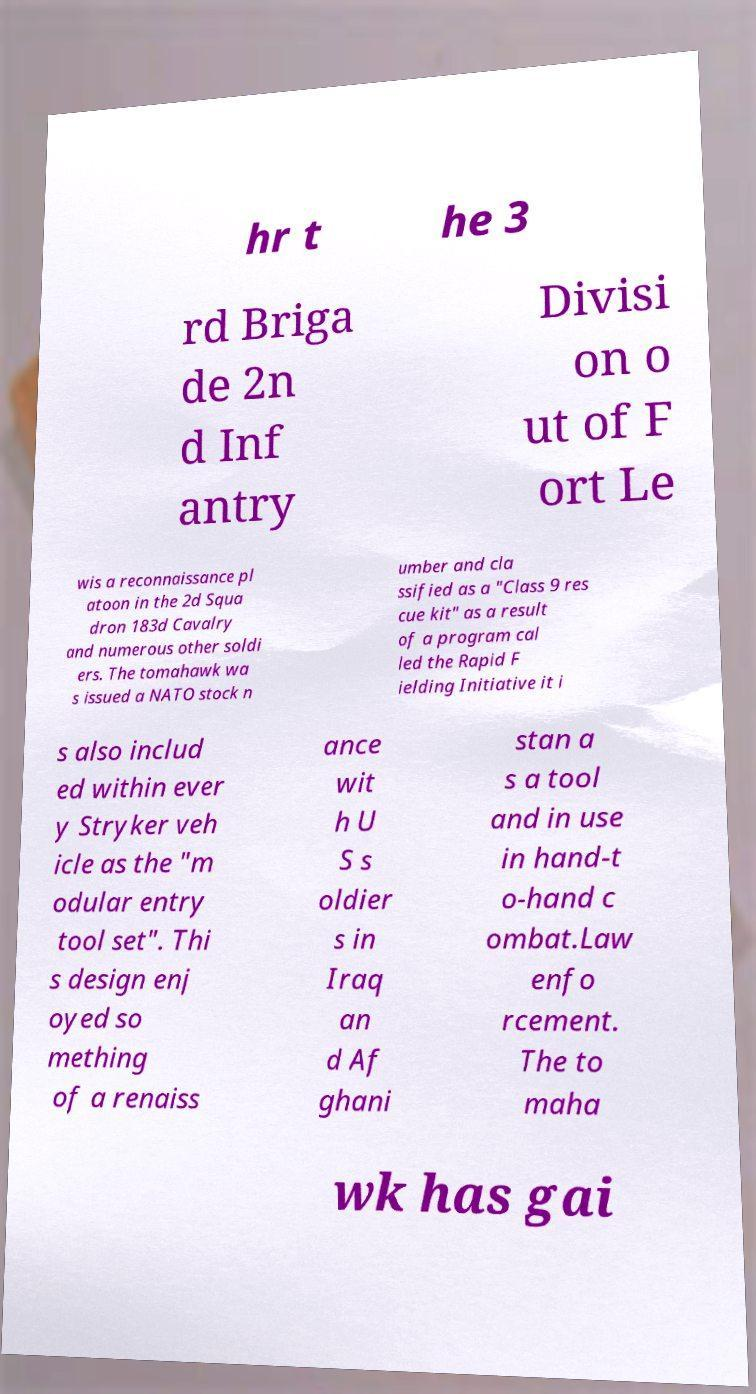For documentation purposes, I need the text within this image transcribed. Could you provide that? hr t he 3 rd Briga de 2n d Inf antry Divisi on o ut of F ort Le wis a reconnaissance pl atoon in the 2d Squa dron 183d Cavalry and numerous other soldi ers. The tomahawk wa s issued a NATO stock n umber and cla ssified as a "Class 9 res cue kit" as a result of a program cal led the Rapid F ielding Initiative it i s also includ ed within ever y Stryker veh icle as the "m odular entry tool set". Thi s design enj oyed so mething of a renaiss ance wit h U S s oldier s in Iraq an d Af ghani stan a s a tool and in use in hand-t o-hand c ombat.Law enfo rcement. The to maha wk has gai 